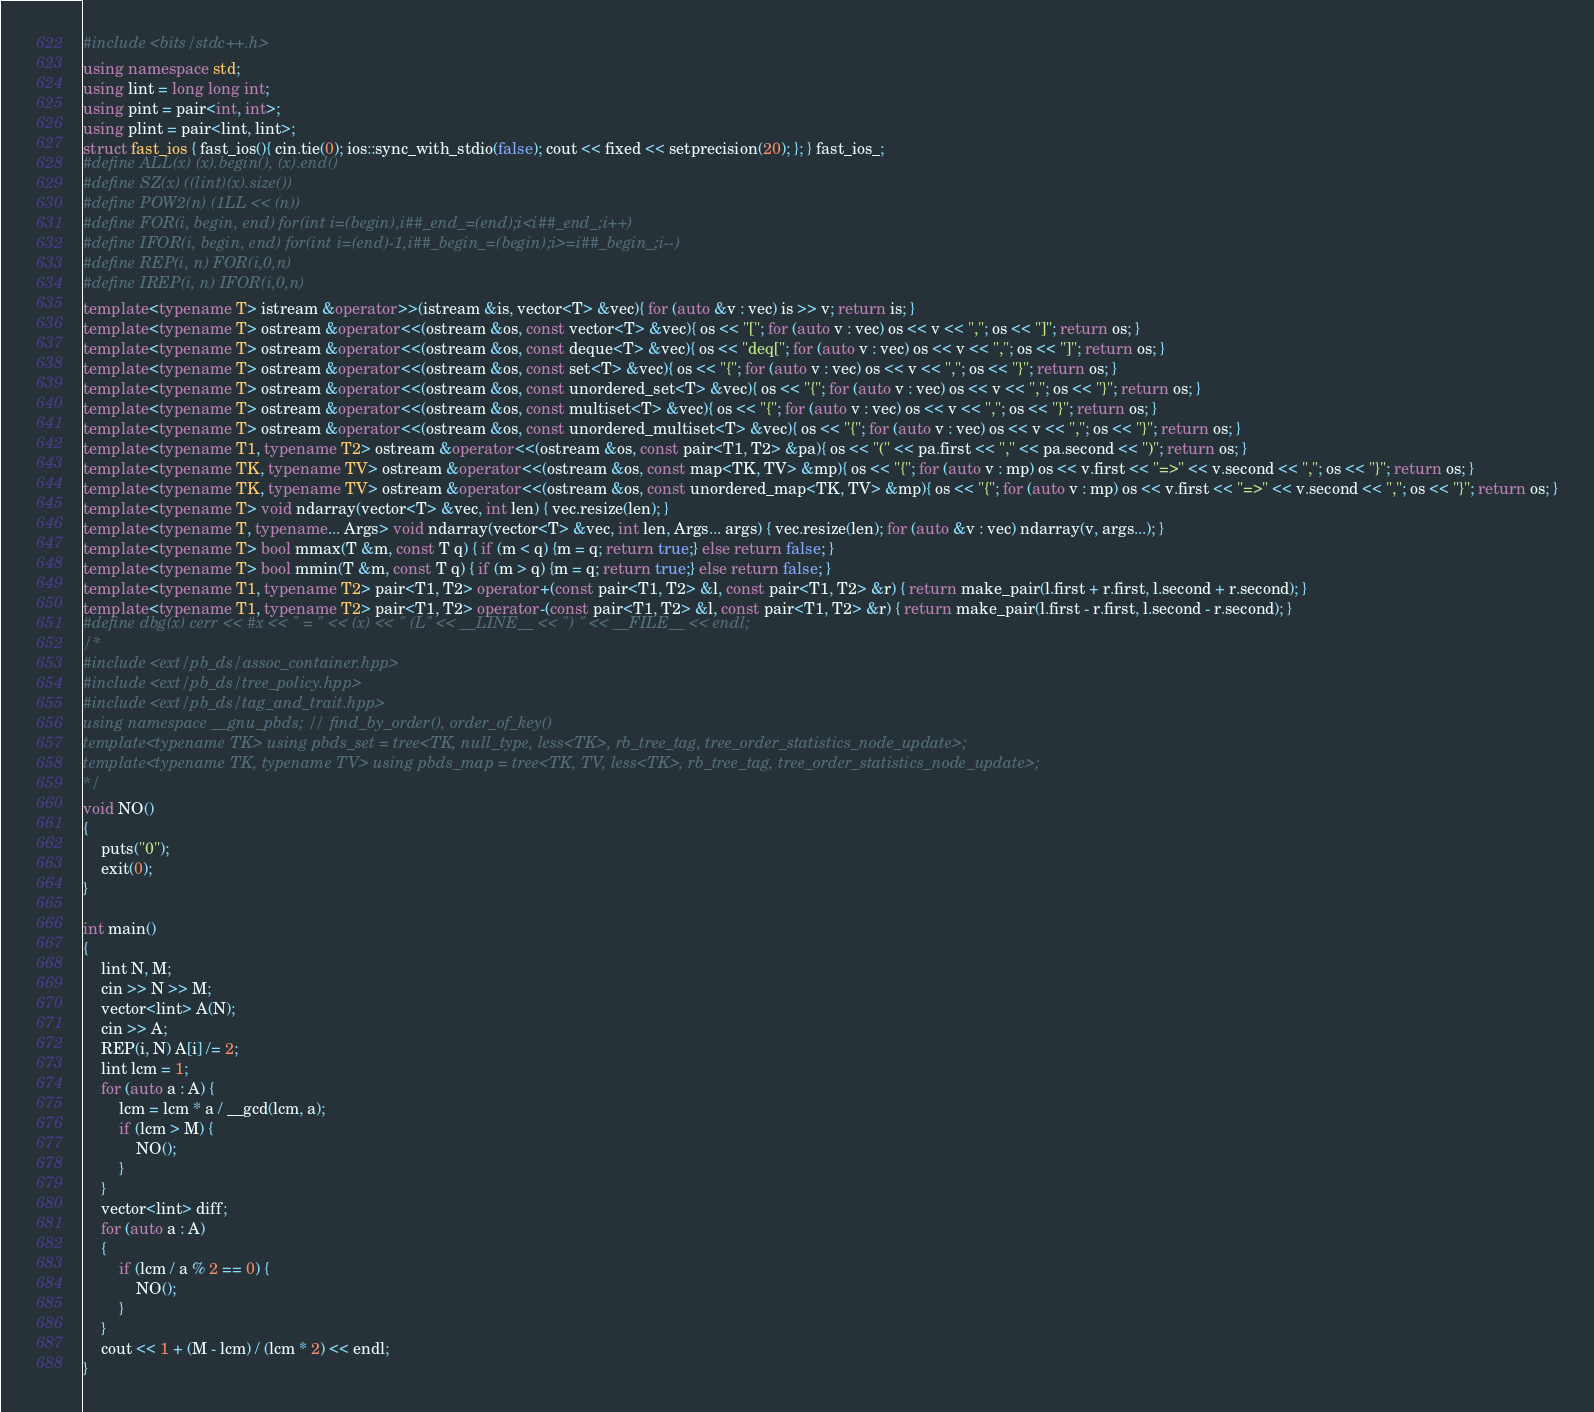<code> <loc_0><loc_0><loc_500><loc_500><_C++_>#include <bits/stdc++.h>
using namespace std;
using lint = long long int;
using pint = pair<int, int>;
using plint = pair<lint, lint>;
struct fast_ios { fast_ios(){ cin.tie(0); ios::sync_with_stdio(false); cout << fixed << setprecision(20); }; } fast_ios_;
#define ALL(x) (x).begin(), (x).end()
#define SZ(x) ((lint)(x).size())
#define POW2(n) (1LL << (n))
#define FOR(i, begin, end) for(int i=(begin),i##_end_=(end);i<i##_end_;i++)
#define IFOR(i, begin, end) for(int i=(end)-1,i##_begin_=(begin);i>=i##_begin_;i--)
#define REP(i, n) FOR(i,0,n)
#define IREP(i, n) IFOR(i,0,n)
template<typename T> istream &operator>>(istream &is, vector<T> &vec){ for (auto &v : vec) is >> v; return is; }
template<typename T> ostream &operator<<(ostream &os, const vector<T> &vec){ os << "["; for (auto v : vec) os << v << ","; os << "]"; return os; }
template<typename T> ostream &operator<<(ostream &os, const deque<T> &vec){ os << "deq["; for (auto v : vec) os << v << ","; os << "]"; return os; }
template<typename T> ostream &operator<<(ostream &os, const set<T> &vec){ os << "{"; for (auto v : vec) os << v << ","; os << "}"; return os; }
template<typename T> ostream &operator<<(ostream &os, const unordered_set<T> &vec){ os << "{"; for (auto v : vec) os << v << ","; os << "}"; return os; }
template<typename T> ostream &operator<<(ostream &os, const multiset<T> &vec){ os << "{"; for (auto v : vec) os << v << ","; os << "}"; return os; }
template<typename T> ostream &operator<<(ostream &os, const unordered_multiset<T> &vec){ os << "{"; for (auto v : vec) os << v << ","; os << "}"; return os; }
template<typename T1, typename T2> ostream &operator<<(ostream &os, const pair<T1, T2> &pa){ os << "(" << pa.first << "," << pa.second << ")"; return os; }
template<typename TK, typename TV> ostream &operator<<(ostream &os, const map<TK, TV> &mp){ os << "{"; for (auto v : mp) os << v.first << "=>" << v.second << ","; os << "}"; return os; }
template<typename TK, typename TV> ostream &operator<<(ostream &os, const unordered_map<TK, TV> &mp){ os << "{"; for (auto v : mp) os << v.first << "=>" << v.second << ","; os << "}"; return os; }
template<typename T> void ndarray(vector<T> &vec, int len) { vec.resize(len); }
template<typename T, typename... Args> void ndarray(vector<T> &vec, int len, Args... args) { vec.resize(len); for (auto &v : vec) ndarray(v, args...); }
template<typename T> bool mmax(T &m, const T q) { if (m < q) {m = q; return true;} else return false; }
template<typename T> bool mmin(T &m, const T q) { if (m > q) {m = q; return true;} else return false; }
template<typename T1, typename T2> pair<T1, T2> operator+(const pair<T1, T2> &l, const pair<T1, T2> &r) { return make_pair(l.first + r.first, l.second + r.second); }
template<typename T1, typename T2> pair<T1, T2> operator-(const pair<T1, T2> &l, const pair<T1, T2> &r) { return make_pair(l.first - r.first, l.second - r.second); }
#define dbg(x) cerr << #x << " = " << (x) << " (L" << __LINE__ << ") " << __FILE__ << endl;
/*
#include <ext/pb_ds/assoc_container.hpp>
#include <ext/pb_ds/tree_policy.hpp>
#include <ext/pb_ds/tag_and_trait.hpp>
using namespace __gnu_pbds; // find_by_order(), order_of_key()
template<typename TK> using pbds_set = tree<TK, null_type, less<TK>, rb_tree_tag, tree_order_statistics_node_update>;
template<typename TK, typename TV> using pbds_map = tree<TK, TV, less<TK>, rb_tree_tag, tree_order_statistics_node_update>;
*/
void NO()
{
    puts("0");
    exit(0);
}

int main()
{
    lint N, M;
    cin >> N >> M;
    vector<lint> A(N);
    cin >> A;
    REP(i, N) A[i] /= 2;
    lint lcm = 1;
    for (auto a : A) {
        lcm = lcm * a / __gcd(lcm, a);
        if (lcm > M) {
            NO();
        }
    }
    vector<lint> diff;
    for (auto a : A)
    {
        if (lcm / a % 2 == 0) {
            NO();
        }
    }
    cout << 1 + (M - lcm) / (lcm * 2) << endl;
}
</code> 